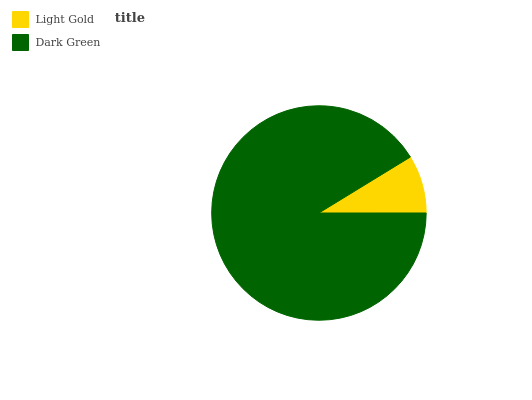Is Light Gold the minimum?
Answer yes or no. Yes. Is Dark Green the maximum?
Answer yes or no. Yes. Is Dark Green the minimum?
Answer yes or no. No. Is Dark Green greater than Light Gold?
Answer yes or no. Yes. Is Light Gold less than Dark Green?
Answer yes or no. Yes. Is Light Gold greater than Dark Green?
Answer yes or no. No. Is Dark Green less than Light Gold?
Answer yes or no. No. Is Dark Green the high median?
Answer yes or no. Yes. Is Light Gold the low median?
Answer yes or no. Yes. Is Light Gold the high median?
Answer yes or no. No. Is Dark Green the low median?
Answer yes or no. No. 